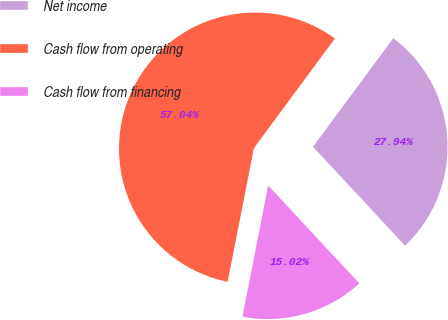Convert chart. <chart><loc_0><loc_0><loc_500><loc_500><pie_chart><fcel>Net income<fcel>Cash flow from operating<fcel>Cash flow from financing<nl><fcel>27.94%<fcel>57.04%<fcel>15.02%<nl></chart> 